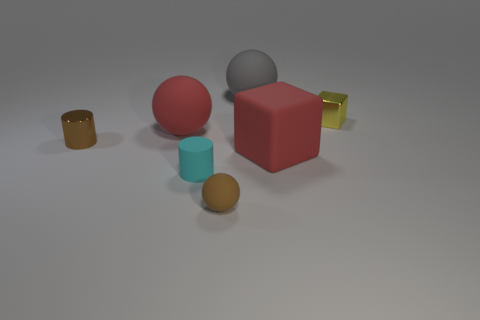How many other objects are the same size as the red rubber ball?
Provide a short and direct response. 2. How big is the brown object behind the tiny cyan rubber object?
Your answer should be very brief. Small. What number of big cubes have the same material as the tiny yellow object?
Your answer should be compact. 0. There is a large red object to the right of the gray thing; is its shape the same as the cyan matte thing?
Your response must be concise. No. What is the shape of the red matte thing that is behind the brown metallic cylinder?
Your response must be concise. Sphere. There is a object that is the same color as the metallic cylinder; what is its size?
Ensure brevity in your answer.  Small. What material is the gray object?
Offer a very short reply. Rubber. The block that is the same size as the gray rubber thing is what color?
Provide a succinct answer. Red. There is a tiny object that is the same color as the tiny shiny cylinder; what is its shape?
Ensure brevity in your answer.  Sphere. Does the cyan rubber thing have the same shape as the big gray object?
Give a very brief answer. No. 